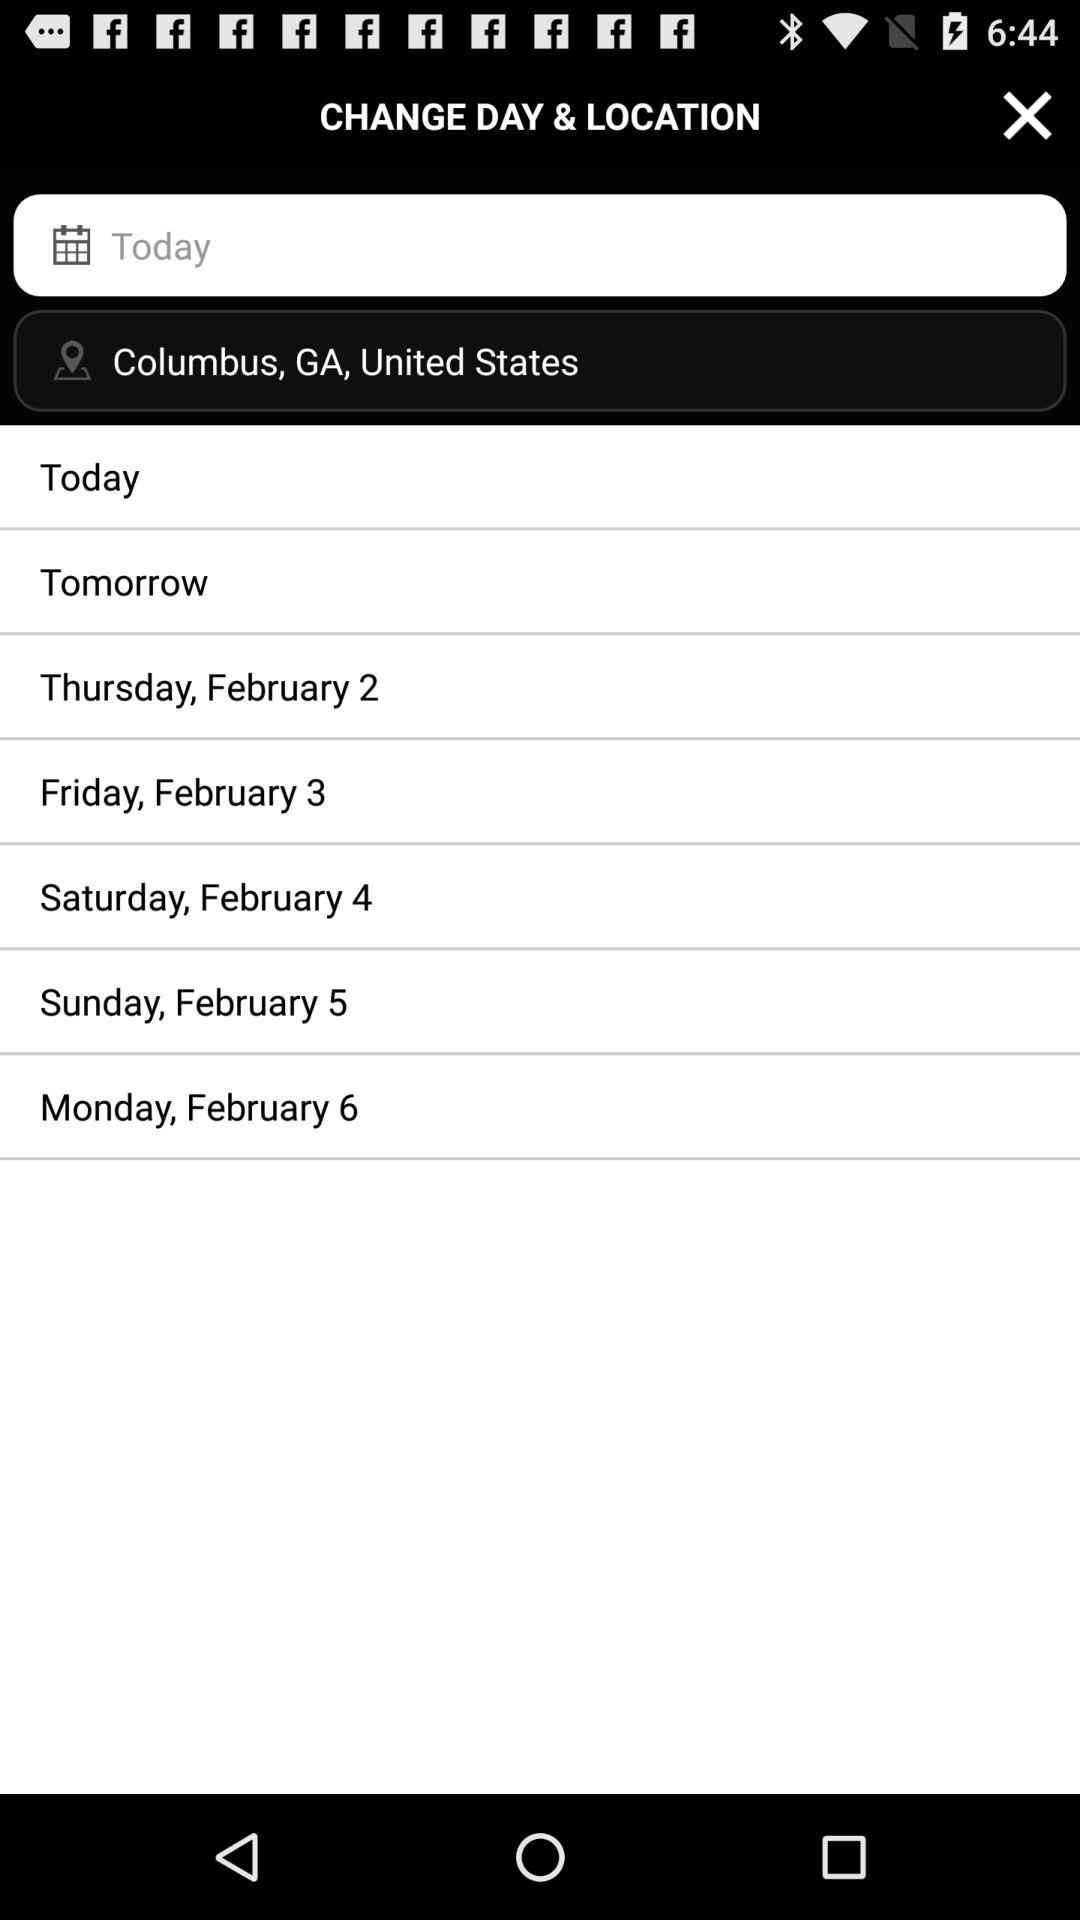What is the day on February 2? The day is Thursday. 